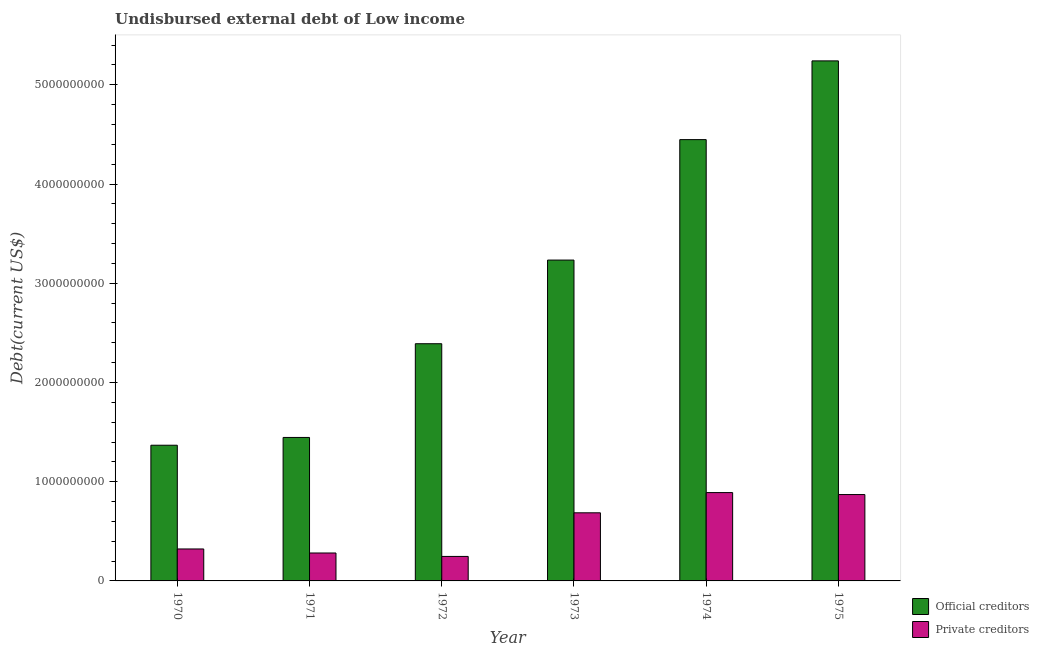How many different coloured bars are there?
Give a very brief answer. 2. How many groups of bars are there?
Offer a very short reply. 6. How many bars are there on the 5th tick from the right?
Provide a short and direct response. 2. What is the label of the 6th group of bars from the left?
Offer a very short reply. 1975. What is the undisbursed external debt of private creditors in 1972?
Make the answer very short. 2.47e+08. Across all years, what is the maximum undisbursed external debt of official creditors?
Offer a terse response. 5.24e+09. Across all years, what is the minimum undisbursed external debt of private creditors?
Keep it short and to the point. 2.47e+08. In which year was the undisbursed external debt of private creditors maximum?
Give a very brief answer. 1974. What is the total undisbursed external debt of official creditors in the graph?
Your answer should be compact. 1.81e+1. What is the difference between the undisbursed external debt of private creditors in 1973 and that in 1974?
Give a very brief answer. -2.04e+08. What is the difference between the undisbursed external debt of private creditors in 1971 and the undisbursed external debt of official creditors in 1972?
Give a very brief answer. 3.47e+07. What is the average undisbursed external debt of private creditors per year?
Your answer should be very brief. 5.50e+08. In the year 1972, what is the difference between the undisbursed external debt of official creditors and undisbursed external debt of private creditors?
Ensure brevity in your answer.  0. What is the ratio of the undisbursed external debt of private creditors in 1970 to that in 1972?
Provide a succinct answer. 1.3. Is the undisbursed external debt of private creditors in 1972 less than that in 1975?
Your response must be concise. Yes. Is the difference between the undisbursed external debt of private creditors in 1971 and 1973 greater than the difference between the undisbursed external debt of official creditors in 1971 and 1973?
Your response must be concise. No. What is the difference between the highest and the second highest undisbursed external debt of private creditors?
Keep it short and to the point. 1.98e+07. What is the difference between the highest and the lowest undisbursed external debt of private creditors?
Offer a very short reply. 6.43e+08. In how many years, is the undisbursed external debt of private creditors greater than the average undisbursed external debt of private creditors taken over all years?
Your answer should be compact. 3. What does the 1st bar from the left in 1975 represents?
Your response must be concise. Official creditors. What does the 2nd bar from the right in 1973 represents?
Ensure brevity in your answer.  Official creditors. What is the difference between two consecutive major ticks on the Y-axis?
Your answer should be compact. 1.00e+09. Are the values on the major ticks of Y-axis written in scientific E-notation?
Offer a very short reply. No. Does the graph contain grids?
Provide a short and direct response. No. Where does the legend appear in the graph?
Your answer should be very brief. Bottom right. How are the legend labels stacked?
Give a very brief answer. Vertical. What is the title of the graph?
Provide a succinct answer. Undisbursed external debt of Low income. Does "Age 65(male)" appear as one of the legend labels in the graph?
Provide a succinct answer. No. What is the label or title of the X-axis?
Keep it short and to the point. Year. What is the label or title of the Y-axis?
Your answer should be very brief. Debt(current US$). What is the Debt(current US$) of Official creditors in 1970?
Offer a terse response. 1.37e+09. What is the Debt(current US$) in Private creditors in 1970?
Ensure brevity in your answer.  3.22e+08. What is the Debt(current US$) in Official creditors in 1971?
Provide a short and direct response. 1.45e+09. What is the Debt(current US$) in Private creditors in 1971?
Offer a terse response. 2.82e+08. What is the Debt(current US$) of Official creditors in 1972?
Offer a terse response. 2.39e+09. What is the Debt(current US$) in Private creditors in 1972?
Give a very brief answer. 2.47e+08. What is the Debt(current US$) in Official creditors in 1973?
Offer a very short reply. 3.23e+09. What is the Debt(current US$) in Private creditors in 1973?
Keep it short and to the point. 6.86e+08. What is the Debt(current US$) in Official creditors in 1974?
Your answer should be very brief. 4.45e+09. What is the Debt(current US$) of Private creditors in 1974?
Offer a very short reply. 8.90e+08. What is the Debt(current US$) in Official creditors in 1975?
Give a very brief answer. 5.24e+09. What is the Debt(current US$) of Private creditors in 1975?
Offer a terse response. 8.71e+08. Across all years, what is the maximum Debt(current US$) in Official creditors?
Ensure brevity in your answer.  5.24e+09. Across all years, what is the maximum Debt(current US$) of Private creditors?
Provide a succinct answer. 8.90e+08. Across all years, what is the minimum Debt(current US$) of Official creditors?
Give a very brief answer. 1.37e+09. Across all years, what is the minimum Debt(current US$) of Private creditors?
Offer a very short reply. 2.47e+08. What is the total Debt(current US$) of Official creditors in the graph?
Provide a short and direct response. 1.81e+1. What is the total Debt(current US$) in Private creditors in the graph?
Give a very brief answer. 3.30e+09. What is the difference between the Debt(current US$) of Official creditors in 1970 and that in 1971?
Your response must be concise. -7.83e+07. What is the difference between the Debt(current US$) of Private creditors in 1970 and that in 1971?
Your answer should be very brief. 4.06e+07. What is the difference between the Debt(current US$) of Official creditors in 1970 and that in 1972?
Give a very brief answer. -1.02e+09. What is the difference between the Debt(current US$) in Private creditors in 1970 and that in 1972?
Make the answer very short. 7.53e+07. What is the difference between the Debt(current US$) of Official creditors in 1970 and that in 1973?
Ensure brevity in your answer.  -1.87e+09. What is the difference between the Debt(current US$) in Private creditors in 1970 and that in 1973?
Your response must be concise. -3.64e+08. What is the difference between the Debt(current US$) of Official creditors in 1970 and that in 1974?
Make the answer very short. -3.08e+09. What is the difference between the Debt(current US$) of Private creditors in 1970 and that in 1974?
Give a very brief answer. -5.68e+08. What is the difference between the Debt(current US$) in Official creditors in 1970 and that in 1975?
Your answer should be very brief. -3.87e+09. What is the difference between the Debt(current US$) in Private creditors in 1970 and that in 1975?
Your answer should be compact. -5.48e+08. What is the difference between the Debt(current US$) of Official creditors in 1971 and that in 1972?
Your response must be concise. -9.45e+08. What is the difference between the Debt(current US$) of Private creditors in 1971 and that in 1972?
Offer a very short reply. 3.47e+07. What is the difference between the Debt(current US$) in Official creditors in 1971 and that in 1973?
Offer a terse response. -1.79e+09. What is the difference between the Debt(current US$) in Private creditors in 1971 and that in 1973?
Keep it short and to the point. -4.05e+08. What is the difference between the Debt(current US$) in Official creditors in 1971 and that in 1974?
Offer a terse response. -3.00e+09. What is the difference between the Debt(current US$) in Private creditors in 1971 and that in 1974?
Keep it short and to the point. -6.09e+08. What is the difference between the Debt(current US$) in Official creditors in 1971 and that in 1975?
Provide a short and direct response. -3.80e+09. What is the difference between the Debt(current US$) in Private creditors in 1971 and that in 1975?
Your answer should be compact. -5.89e+08. What is the difference between the Debt(current US$) in Official creditors in 1972 and that in 1973?
Provide a succinct answer. -8.43e+08. What is the difference between the Debt(current US$) in Private creditors in 1972 and that in 1973?
Make the answer very short. -4.40e+08. What is the difference between the Debt(current US$) in Official creditors in 1972 and that in 1974?
Offer a very short reply. -2.06e+09. What is the difference between the Debt(current US$) of Private creditors in 1972 and that in 1974?
Give a very brief answer. -6.43e+08. What is the difference between the Debt(current US$) of Official creditors in 1972 and that in 1975?
Your answer should be very brief. -2.85e+09. What is the difference between the Debt(current US$) in Private creditors in 1972 and that in 1975?
Offer a very short reply. -6.24e+08. What is the difference between the Debt(current US$) of Official creditors in 1973 and that in 1974?
Offer a very short reply. -1.21e+09. What is the difference between the Debt(current US$) in Private creditors in 1973 and that in 1974?
Provide a short and direct response. -2.04e+08. What is the difference between the Debt(current US$) of Official creditors in 1973 and that in 1975?
Provide a short and direct response. -2.01e+09. What is the difference between the Debt(current US$) in Private creditors in 1973 and that in 1975?
Your answer should be compact. -1.84e+08. What is the difference between the Debt(current US$) in Official creditors in 1974 and that in 1975?
Offer a terse response. -7.94e+08. What is the difference between the Debt(current US$) in Private creditors in 1974 and that in 1975?
Your answer should be very brief. 1.98e+07. What is the difference between the Debt(current US$) of Official creditors in 1970 and the Debt(current US$) of Private creditors in 1971?
Give a very brief answer. 1.09e+09. What is the difference between the Debt(current US$) in Official creditors in 1970 and the Debt(current US$) in Private creditors in 1972?
Your answer should be compact. 1.12e+09. What is the difference between the Debt(current US$) of Official creditors in 1970 and the Debt(current US$) of Private creditors in 1973?
Give a very brief answer. 6.81e+08. What is the difference between the Debt(current US$) in Official creditors in 1970 and the Debt(current US$) in Private creditors in 1974?
Your answer should be very brief. 4.77e+08. What is the difference between the Debt(current US$) of Official creditors in 1970 and the Debt(current US$) of Private creditors in 1975?
Offer a very short reply. 4.97e+08. What is the difference between the Debt(current US$) of Official creditors in 1971 and the Debt(current US$) of Private creditors in 1972?
Offer a very short reply. 1.20e+09. What is the difference between the Debt(current US$) of Official creditors in 1971 and the Debt(current US$) of Private creditors in 1973?
Give a very brief answer. 7.59e+08. What is the difference between the Debt(current US$) of Official creditors in 1971 and the Debt(current US$) of Private creditors in 1974?
Your answer should be compact. 5.56e+08. What is the difference between the Debt(current US$) in Official creditors in 1971 and the Debt(current US$) in Private creditors in 1975?
Offer a very short reply. 5.75e+08. What is the difference between the Debt(current US$) in Official creditors in 1972 and the Debt(current US$) in Private creditors in 1973?
Provide a succinct answer. 1.70e+09. What is the difference between the Debt(current US$) of Official creditors in 1972 and the Debt(current US$) of Private creditors in 1974?
Your answer should be compact. 1.50e+09. What is the difference between the Debt(current US$) in Official creditors in 1972 and the Debt(current US$) in Private creditors in 1975?
Your answer should be compact. 1.52e+09. What is the difference between the Debt(current US$) in Official creditors in 1973 and the Debt(current US$) in Private creditors in 1974?
Offer a terse response. 2.34e+09. What is the difference between the Debt(current US$) in Official creditors in 1973 and the Debt(current US$) in Private creditors in 1975?
Make the answer very short. 2.36e+09. What is the difference between the Debt(current US$) in Official creditors in 1974 and the Debt(current US$) in Private creditors in 1975?
Make the answer very short. 3.58e+09. What is the average Debt(current US$) of Official creditors per year?
Your response must be concise. 3.02e+09. What is the average Debt(current US$) of Private creditors per year?
Ensure brevity in your answer.  5.50e+08. In the year 1970, what is the difference between the Debt(current US$) of Official creditors and Debt(current US$) of Private creditors?
Your response must be concise. 1.05e+09. In the year 1971, what is the difference between the Debt(current US$) of Official creditors and Debt(current US$) of Private creditors?
Provide a short and direct response. 1.16e+09. In the year 1972, what is the difference between the Debt(current US$) of Official creditors and Debt(current US$) of Private creditors?
Provide a succinct answer. 2.14e+09. In the year 1973, what is the difference between the Debt(current US$) of Official creditors and Debt(current US$) of Private creditors?
Provide a succinct answer. 2.55e+09. In the year 1974, what is the difference between the Debt(current US$) in Official creditors and Debt(current US$) in Private creditors?
Offer a very short reply. 3.56e+09. In the year 1975, what is the difference between the Debt(current US$) in Official creditors and Debt(current US$) in Private creditors?
Keep it short and to the point. 4.37e+09. What is the ratio of the Debt(current US$) in Official creditors in 1970 to that in 1971?
Provide a succinct answer. 0.95. What is the ratio of the Debt(current US$) in Private creditors in 1970 to that in 1971?
Make the answer very short. 1.14. What is the ratio of the Debt(current US$) in Official creditors in 1970 to that in 1972?
Your response must be concise. 0.57. What is the ratio of the Debt(current US$) of Private creditors in 1970 to that in 1972?
Provide a succinct answer. 1.3. What is the ratio of the Debt(current US$) of Official creditors in 1970 to that in 1973?
Your response must be concise. 0.42. What is the ratio of the Debt(current US$) of Private creditors in 1970 to that in 1973?
Your answer should be very brief. 0.47. What is the ratio of the Debt(current US$) in Official creditors in 1970 to that in 1974?
Offer a very short reply. 0.31. What is the ratio of the Debt(current US$) of Private creditors in 1970 to that in 1974?
Provide a succinct answer. 0.36. What is the ratio of the Debt(current US$) in Official creditors in 1970 to that in 1975?
Keep it short and to the point. 0.26. What is the ratio of the Debt(current US$) of Private creditors in 1970 to that in 1975?
Offer a terse response. 0.37. What is the ratio of the Debt(current US$) of Official creditors in 1971 to that in 1972?
Give a very brief answer. 0.6. What is the ratio of the Debt(current US$) of Private creditors in 1971 to that in 1972?
Your response must be concise. 1.14. What is the ratio of the Debt(current US$) in Official creditors in 1971 to that in 1973?
Your answer should be very brief. 0.45. What is the ratio of the Debt(current US$) of Private creditors in 1971 to that in 1973?
Keep it short and to the point. 0.41. What is the ratio of the Debt(current US$) in Official creditors in 1971 to that in 1974?
Make the answer very short. 0.33. What is the ratio of the Debt(current US$) in Private creditors in 1971 to that in 1974?
Provide a succinct answer. 0.32. What is the ratio of the Debt(current US$) in Official creditors in 1971 to that in 1975?
Ensure brevity in your answer.  0.28. What is the ratio of the Debt(current US$) in Private creditors in 1971 to that in 1975?
Offer a very short reply. 0.32. What is the ratio of the Debt(current US$) in Official creditors in 1972 to that in 1973?
Give a very brief answer. 0.74. What is the ratio of the Debt(current US$) of Private creditors in 1972 to that in 1973?
Your response must be concise. 0.36. What is the ratio of the Debt(current US$) of Official creditors in 1972 to that in 1974?
Offer a very short reply. 0.54. What is the ratio of the Debt(current US$) in Private creditors in 1972 to that in 1974?
Give a very brief answer. 0.28. What is the ratio of the Debt(current US$) in Official creditors in 1972 to that in 1975?
Provide a succinct answer. 0.46. What is the ratio of the Debt(current US$) in Private creditors in 1972 to that in 1975?
Offer a very short reply. 0.28. What is the ratio of the Debt(current US$) of Official creditors in 1973 to that in 1974?
Provide a succinct answer. 0.73. What is the ratio of the Debt(current US$) in Private creditors in 1973 to that in 1974?
Your answer should be compact. 0.77. What is the ratio of the Debt(current US$) in Official creditors in 1973 to that in 1975?
Your answer should be very brief. 0.62. What is the ratio of the Debt(current US$) of Private creditors in 1973 to that in 1975?
Provide a succinct answer. 0.79. What is the ratio of the Debt(current US$) of Official creditors in 1974 to that in 1975?
Offer a very short reply. 0.85. What is the ratio of the Debt(current US$) in Private creditors in 1974 to that in 1975?
Provide a succinct answer. 1.02. What is the difference between the highest and the second highest Debt(current US$) of Official creditors?
Offer a very short reply. 7.94e+08. What is the difference between the highest and the second highest Debt(current US$) of Private creditors?
Make the answer very short. 1.98e+07. What is the difference between the highest and the lowest Debt(current US$) in Official creditors?
Give a very brief answer. 3.87e+09. What is the difference between the highest and the lowest Debt(current US$) of Private creditors?
Your answer should be very brief. 6.43e+08. 